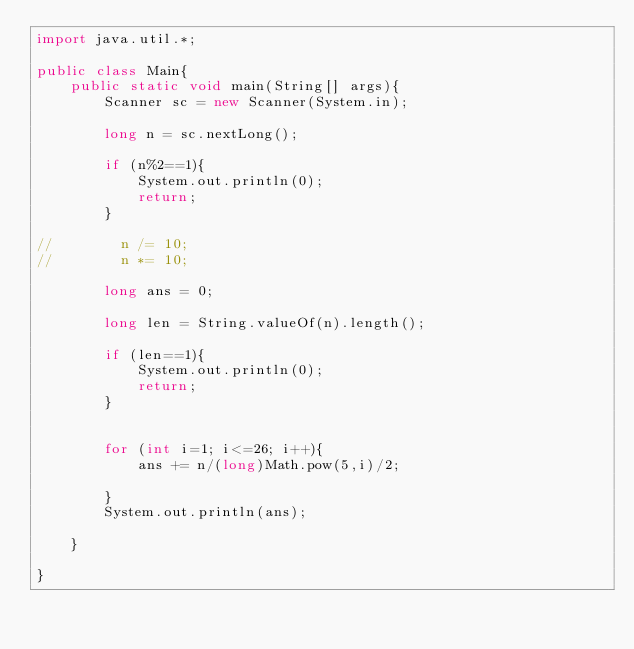Convert code to text. <code><loc_0><loc_0><loc_500><loc_500><_Java_>import java.util.*;

public class Main{
    public static void main(String[] args){
        Scanner sc = new Scanner(System.in);

        long n = sc.nextLong();

        if (n%2==1){
            System.out.println(0);
            return;
        }

//        n /= 10;
//        n *= 10;

        long ans = 0;

        long len = String.valueOf(n).length();

        if (len==1){
            System.out.println(0);
            return;
        }


        for (int i=1; i<=26; i++){
            ans += n/(long)Math.pow(5,i)/2;

        }
        System.out.println(ans);

    }

}
</code> 